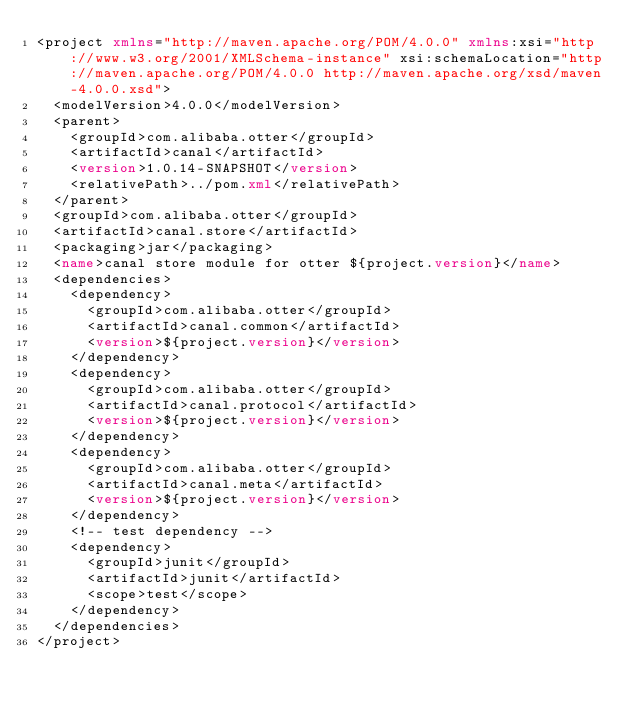Convert code to text. <code><loc_0><loc_0><loc_500><loc_500><_XML_><project xmlns="http://maven.apache.org/POM/4.0.0" xmlns:xsi="http://www.w3.org/2001/XMLSchema-instance" xsi:schemaLocation="http://maven.apache.org/POM/4.0.0 http://maven.apache.org/xsd/maven-4.0.0.xsd">
	<modelVersion>4.0.0</modelVersion>
	<parent>
		<groupId>com.alibaba.otter</groupId>
		<artifactId>canal</artifactId>
		<version>1.0.14-SNAPSHOT</version>
		<relativePath>../pom.xml</relativePath>
	</parent>
	<groupId>com.alibaba.otter</groupId>
	<artifactId>canal.store</artifactId>
	<packaging>jar</packaging>
	<name>canal store module for otter ${project.version}</name>
	<dependencies>
		<dependency>
			<groupId>com.alibaba.otter</groupId>
			<artifactId>canal.common</artifactId>
			<version>${project.version}</version>
		</dependency>
		<dependency>
			<groupId>com.alibaba.otter</groupId>
			<artifactId>canal.protocol</artifactId>
			<version>${project.version}</version>
		</dependency>
		<dependency>
			<groupId>com.alibaba.otter</groupId>
			<artifactId>canal.meta</artifactId>
			<version>${project.version}</version>
		</dependency>
		<!-- test dependency -->
		<dependency>
			<groupId>junit</groupId>
			<artifactId>junit</artifactId>
			<scope>test</scope>
		</dependency>
	</dependencies>
</project>
</code> 